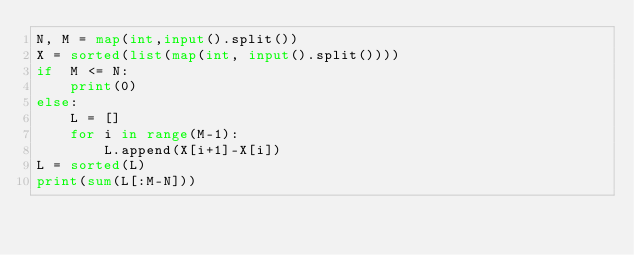Convert code to text. <code><loc_0><loc_0><loc_500><loc_500><_Python_>N, M = map(int,input().split())
X = sorted(list(map(int, input().split())))
if  M <= N:
    print(0)
else:
    L = []
    for i in range(M-1):
        L.append(X[i+1]-X[i])
L = sorted(L)
print(sum(L[:M-N]))</code> 